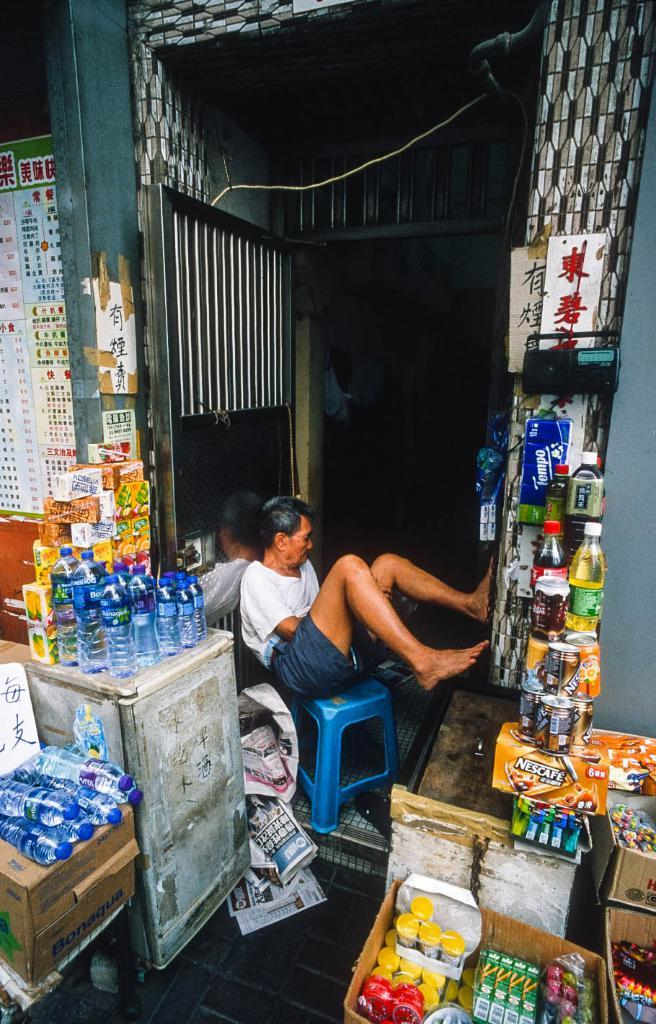Provide a one-sentence caption for the provided image. A man sits in the doorway among products such as Nescafe and Tempo. 